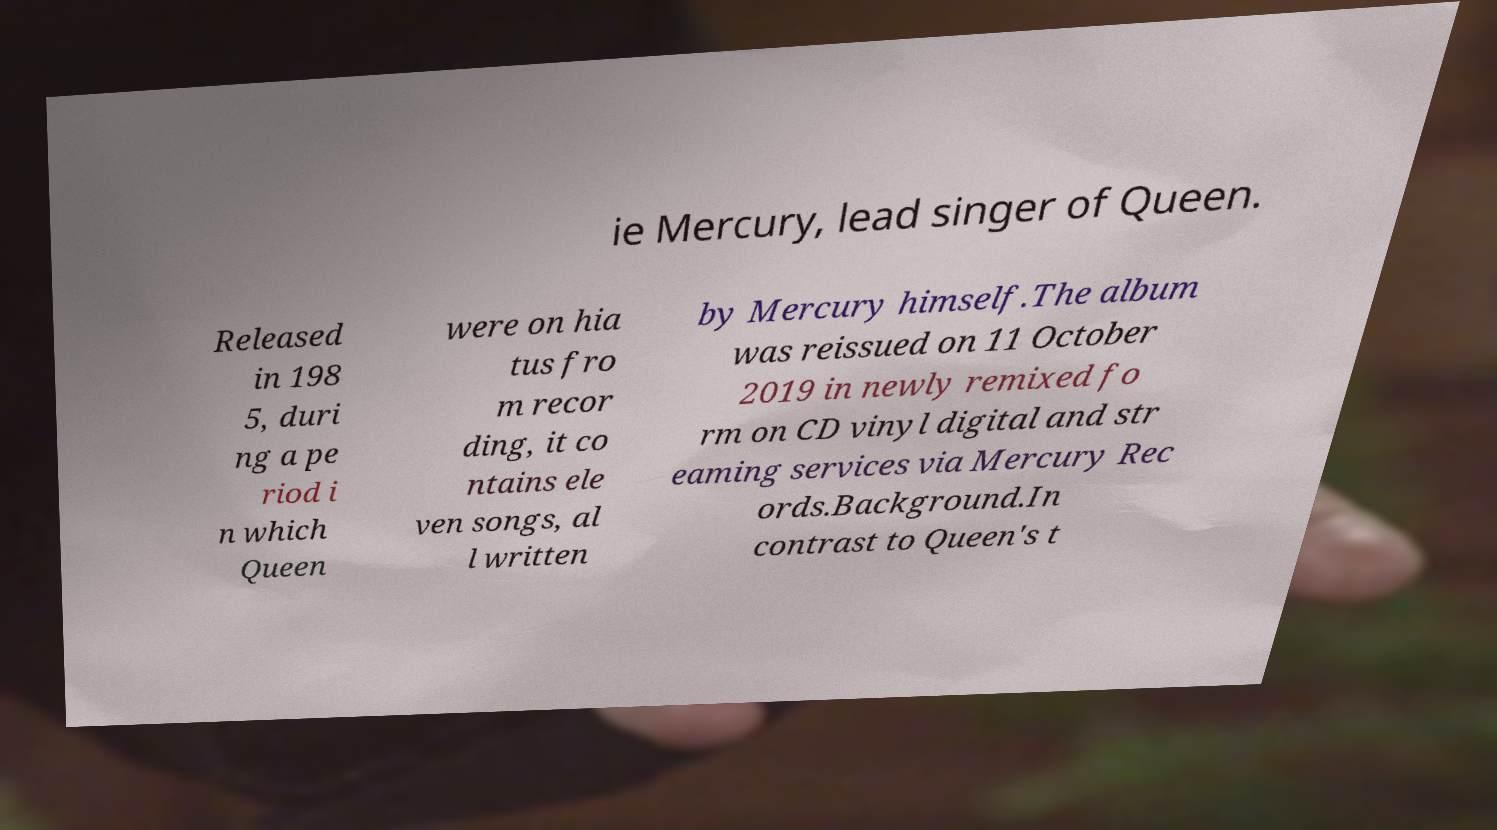Could you extract and type out the text from this image? ie Mercury, lead singer of Queen. Released in 198 5, duri ng a pe riod i n which Queen were on hia tus fro m recor ding, it co ntains ele ven songs, al l written by Mercury himself.The album was reissued on 11 October 2019 in newly remixed fo rm on CD vinyl digital and str eaming services via Mercury Rec ords.Background.In contrast to Queen's t 